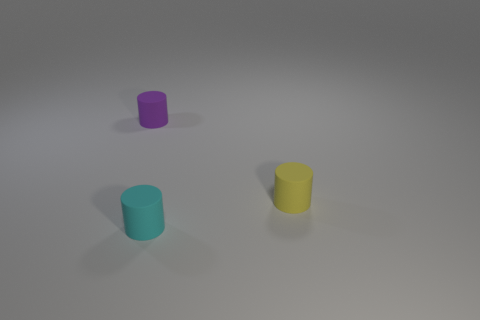How many purple objects are the same shape as the small cyan rubber thing?
Keep it short and to the point. 1. Does the cylinder that is right of the cyan rubber object have the same color as the object that is in front of the small yellow cylinder?
Give a very brief answer. No. What is the material of the cyan cylinder that is the same size as the yellow rubber cylinder?
Offer a terse response. Rubber. Are there any purple metallic blocks that have the same size as the cyan object?
Your response must be concise. No. Is the number of yellow rubber cylinders to the right of the small cyan cylinder less than the number of tiny yellow rubber objects?
Your answer should be compact. No. Are there fewer purple rubber objects that are in front of the cyan matte object than small yellow rubber things that are behind the tiny purple matte object?
Your answer should be compact. No. What number of cubes are either tiny cyan rubber objects or small purple matte things?
Your answer should be very brief. 0. Does the thing behind the small yellow object have the same material as the object in front of the yellow matte thing?
Give a very brief answer. Yes. There is a purple matte object that is the same size as the cyan cylinder; what shape is it?
Make the answer very short. Cylinder. How many blue things are either matte cylinders or big rubber balls?
Offer a terse response. 0. 